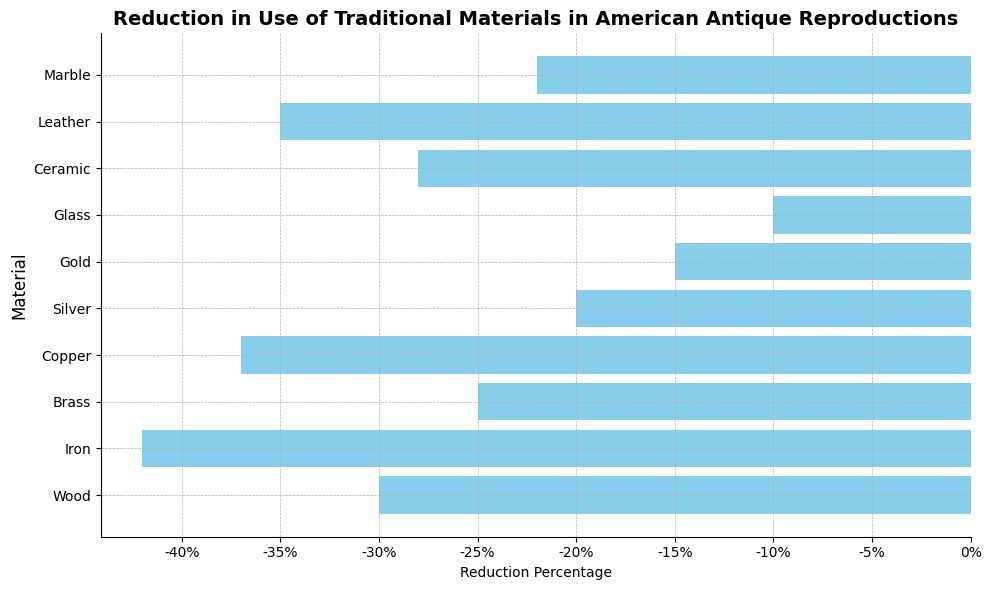Which material has the largest reduction in its use in American antique reproductions? The material with the largest reduction percentage bar will be the longest bar extending to the left
Answer: Iron What is the difference in reduction percentage between the highest and lowest reduced materials? The highest reduction is Iron at -42% and the lowest is Gold at -15%. The difference is -42% - (-15%) = -27%
Answer: 27% Which materials have reduction percentages greater than -30%? By visually inspecting the lengths of the bars, materials with reduction percentages greater than -30% are Wood, Brass, Silver, Gold, Glass, and Marble
Answer: Wood, Brass, Silver, Gold, Glass, Marble What is the average reduction percentage of Iron, Copper, and Leather? Sum the percentages of Iron (-42), Copper (-37), and Leather (-35), then divide by 3: (-42 - 37 - 35) / 3 = -38%
Answer: -38% Which material has a reduction percentage closest to the average reduction percentage of all materials? First calculate the average percentage: (-30 - 42 - 25 - 37 - 20 - 15 - 10 - 28 - 35 - 22) / 10 = -26.4%. Marble has -28%, which is closest to -26.4%
Answer: Ceramic Are there any materials with a reduction percentage exactly equal to -20%? By checking the bars, Silver has a reduction percentage exactly equal to -20%
Answer: Silver What is the reduction percentage difference between Wood and Leather? Reduction percentage of Wood is -30% and Leather is -35%, thus difference is -30% - (-35%) = 5%
Answer: 5% Which material shows the least reduction in its use? The least reduction will have the bar extending less far to the left, which is Glass at -10%
Answer: Glass 